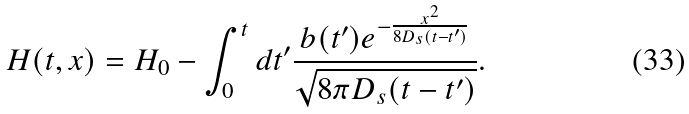<formula> <loc_0><loc_0><loc_500><loc_500>H ( t , x ) = H _ { 0 } - \int _ { 0 } ^ { t } d t ^ { \prime } \frac { b ( t ^ { \prime } ) e ^ { - \frac { x ^ { 2 } } { 8 D _ { s } ( t - t ^ { \prime } ) } } } { \sqrt { 8 \pi D _ { s } ( t - t ^ { \prime } ) } } .</formula> 